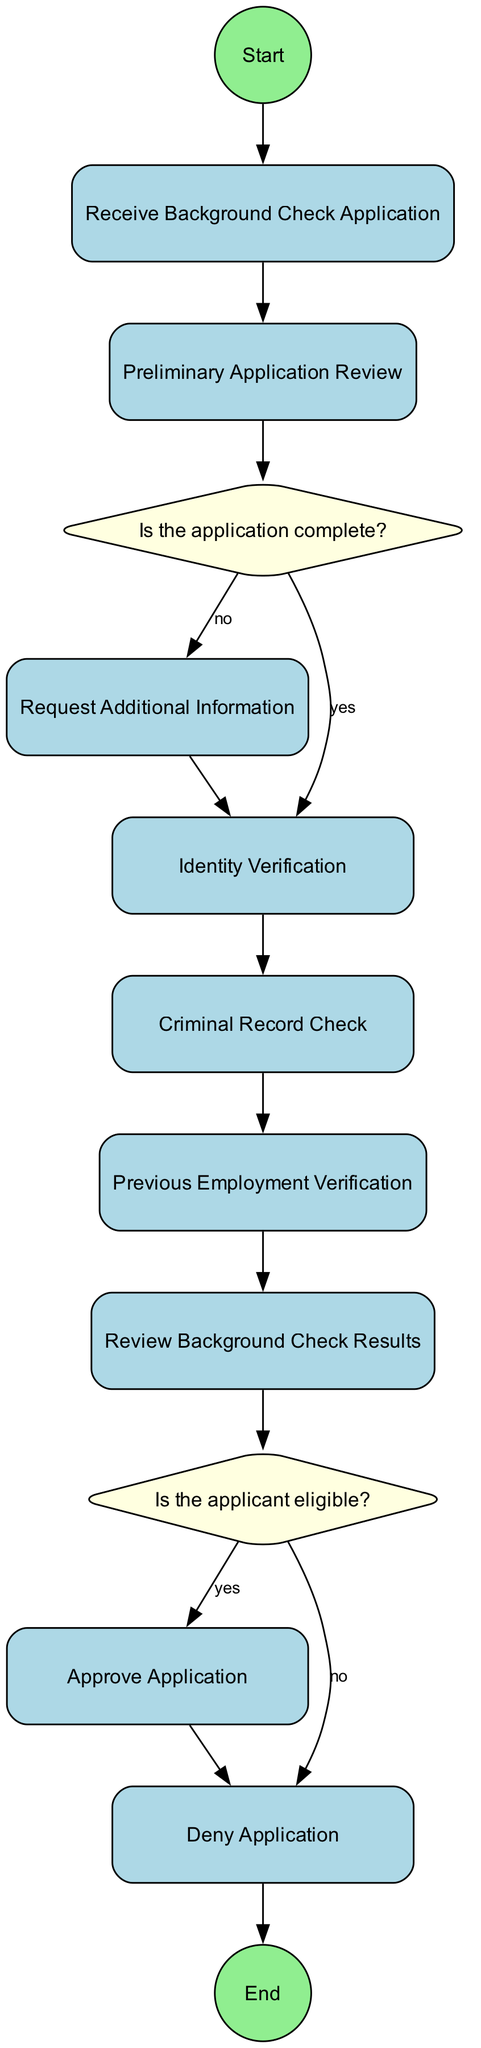What is the first step in the process? The first step is labeled "Start Process," which indicates the beginning of the flowchart.
Answer: Start Process How many decision points are in the flowchart? There are two decision points in the flowchart: "Is the application complete?" and "Is the applicant eligible?"
Answer: 2 What action occurs if the application is not complete? If the application is not complete, the action taken is "Request Additional Information."
Answer: Request Additional Information What action follows after verifying the applicant's identity? After verifying the applicant's identity, the next action is "Criminal Record Check."
Answer: Criminal Record Check What happens if the applicant is found eligible? If the applicant is found eligible, the following action is to "Approve Application."
Answer: Approve Application What type of node is "Is the application complete?" "Is the application complete?" is a decision node, as it evaluates a condition to determine the flow of the process.
Answer: Decision What is the last step in the process? The last step in the process is labeled "End Process," marking the completion of the flowchart.
Answer: End Process What is the process that occurs after reviewing background check results? After reviewing background check results, the process moves to "Is the applicant eligible?" to determine the next steps.
Answer: Is the applicant eligible? What notification is given if the applicant's background check is denied? If the applicant's background check is denied, they are notified of the denial and provided with reasons.
Answer: Notify applicant of background check denial and provide reasons 